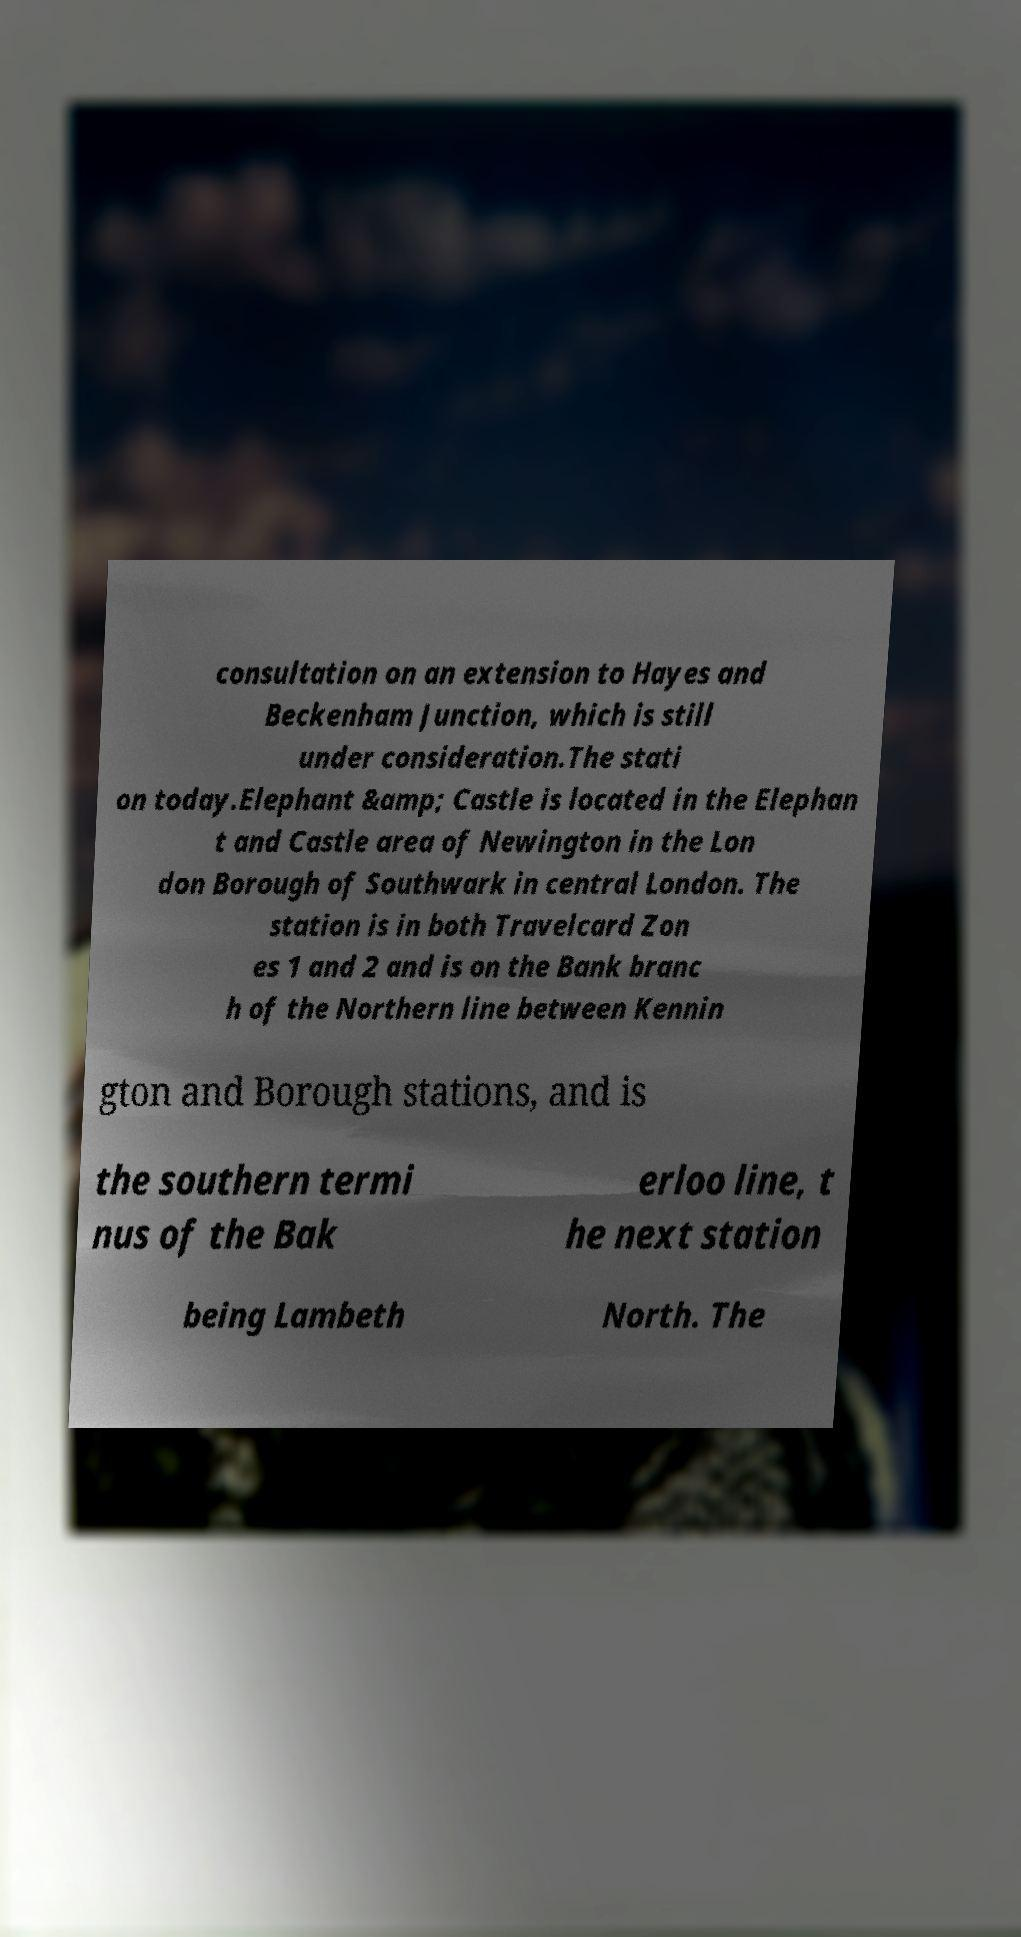Can you read and provide the text displayed in the image?This photo seems to have some interesting text. Can you extract and type it out for me? consultation on an extension to Hayes and Beckenham Junction, which is still under consideration.The stati on today.Elephant &amp; Castle is located in the Elephan t and Castle area of Newington in the Lon don Borough of Southwark in central London. The station is in both Travelcard Zon es 1 and 2 and is on the Bank branc h of the Northern line between Kennin gton and Borough stations, and is the southern termi nus of the Bak erloo line, t he next station being Lambeth North. The 